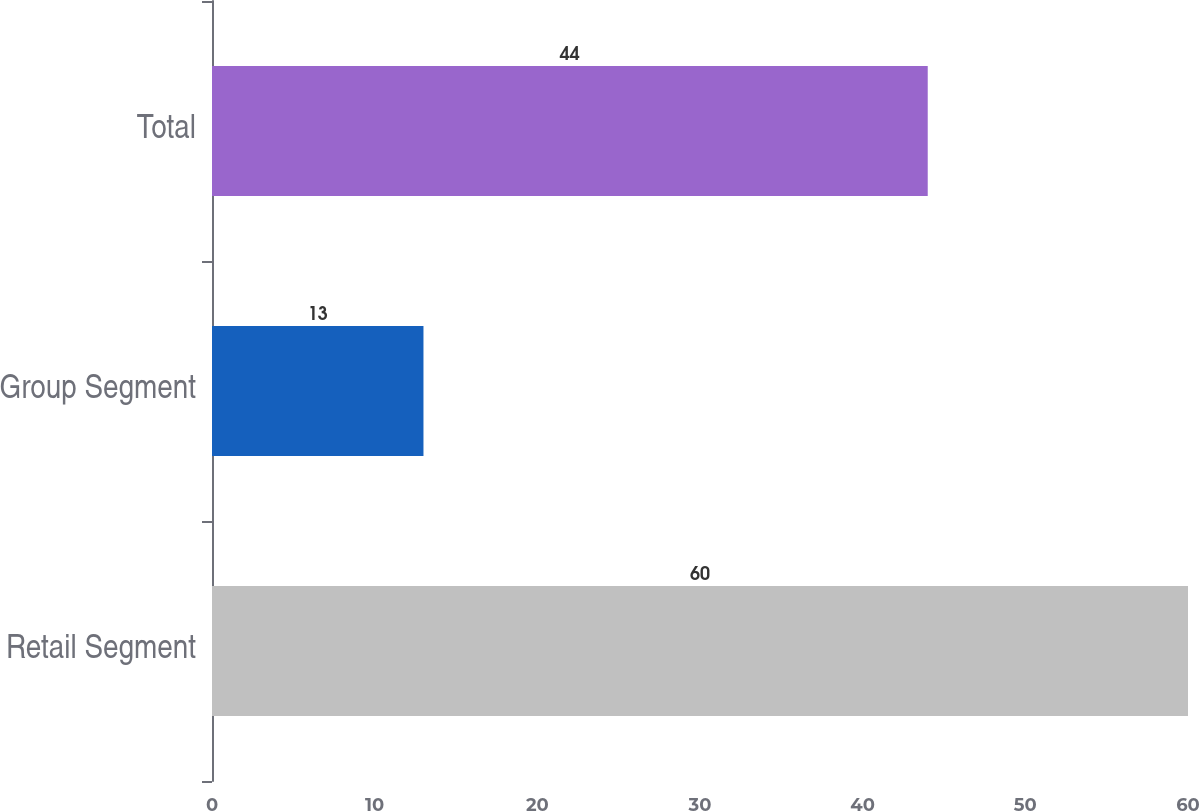<chart> <loc_0><loc_0><loc_500><loc_500><bar_chart><fcel>Retail Segment<fcel>Group Segment<fcel>Total<nl><fcel>60<fcel>13<fcel>44<nl></chart> 